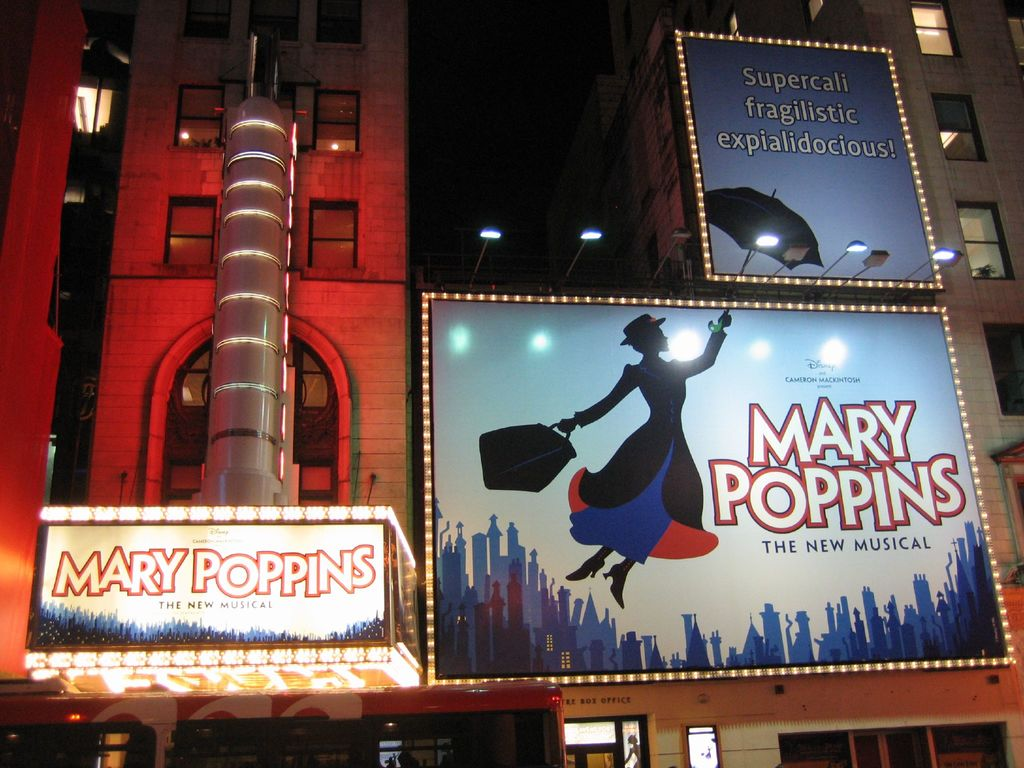What is this photo about? The photo splendidly captures the vibrant and welcoming atmosphere of a theater during the showcase of 'Mary Poppins The New Musical.' It features the theater's facade lit up with a brightly illuminated marquee that spells out the musical's title. Surrounding billboards paint a magical scene with illustrations of Mary Poppins soaring above a city skyline, embodying the spirit and charm of the musical. The phrase 'Supercalifragilisticexpialidocious!' is prominently displayed, adding a touch of whimsy and nostalgia that is famously associated with this beloved character. This image not only promotes the musical but also conveys the enchanting experience audiences can expect, making it a brilliant testament to the timeless appeal of Mary Poppins. 